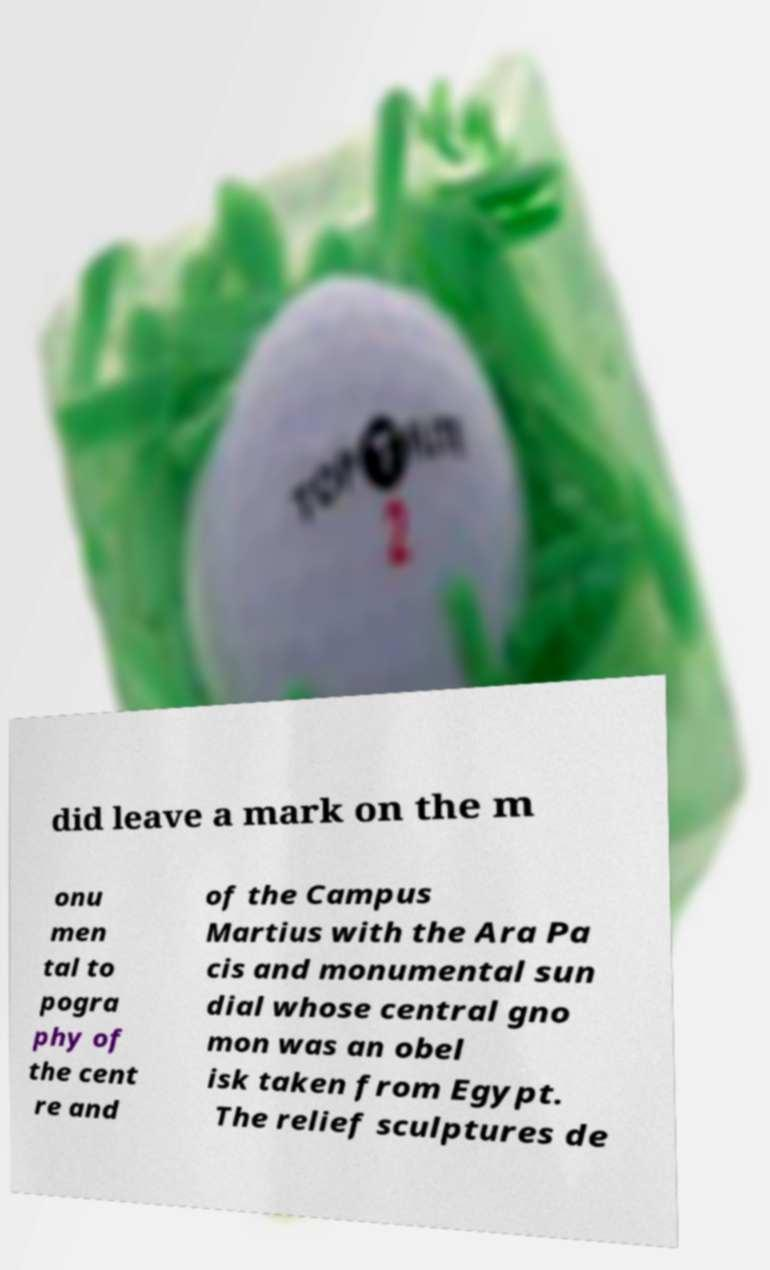There's text embedded in this image that I need extracted. Can you transcribe it verbatim? did leave a mark on the m onu men tal to pogra phy of the cent re and of the Campus Martius with the Ara Pa cis and monumental sun dial whose central gno mon was an obel isk taken from Egypt. The relief sculptures de 